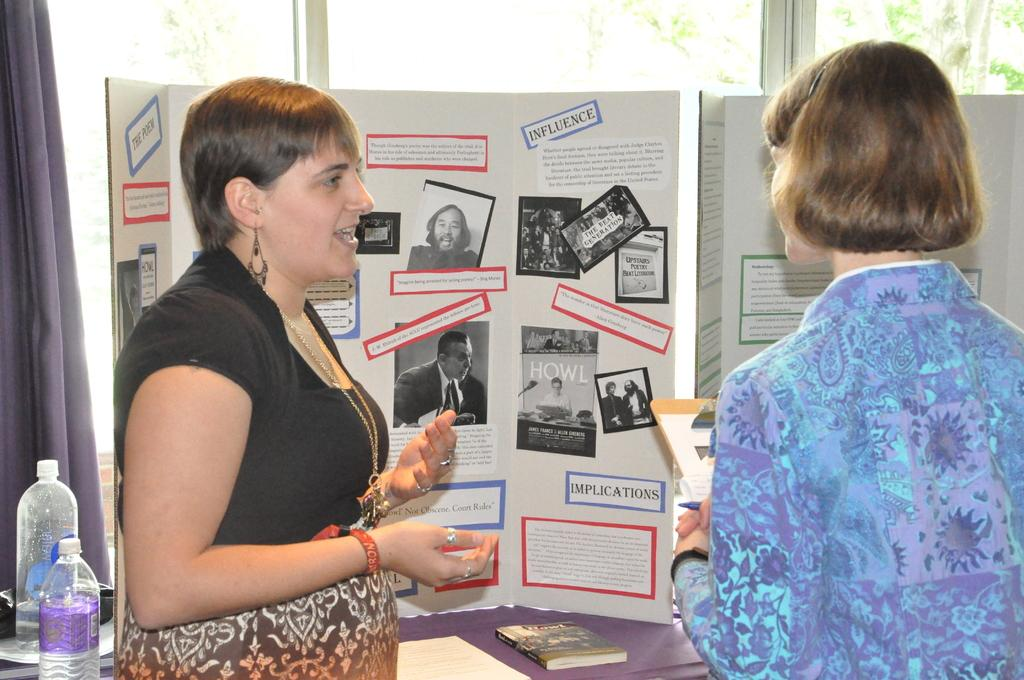How many women are present in the image? There are two women standing in the image. What else can be seen in the image besides the women? Bottles and photos are visible in the image. What degree does the achiever in the image hold? There is no mention of an achiever or degree in the image. 